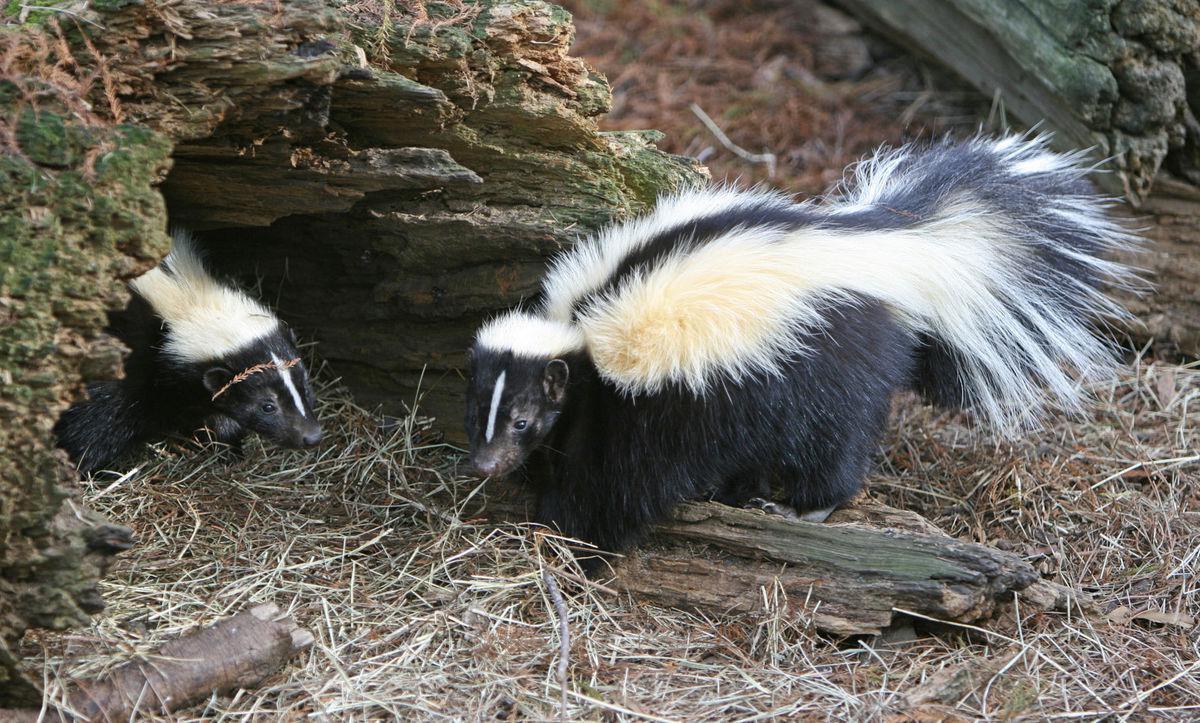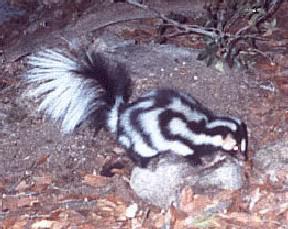The first image is the image on the left, the second image is the image on the right. For the images shown, is this caption "The left image features at least one skunk with a bold white stripe that starts at its head, and the right image features a skunk with more random and numerous stripes." true? Answer yes or no. Yes. 